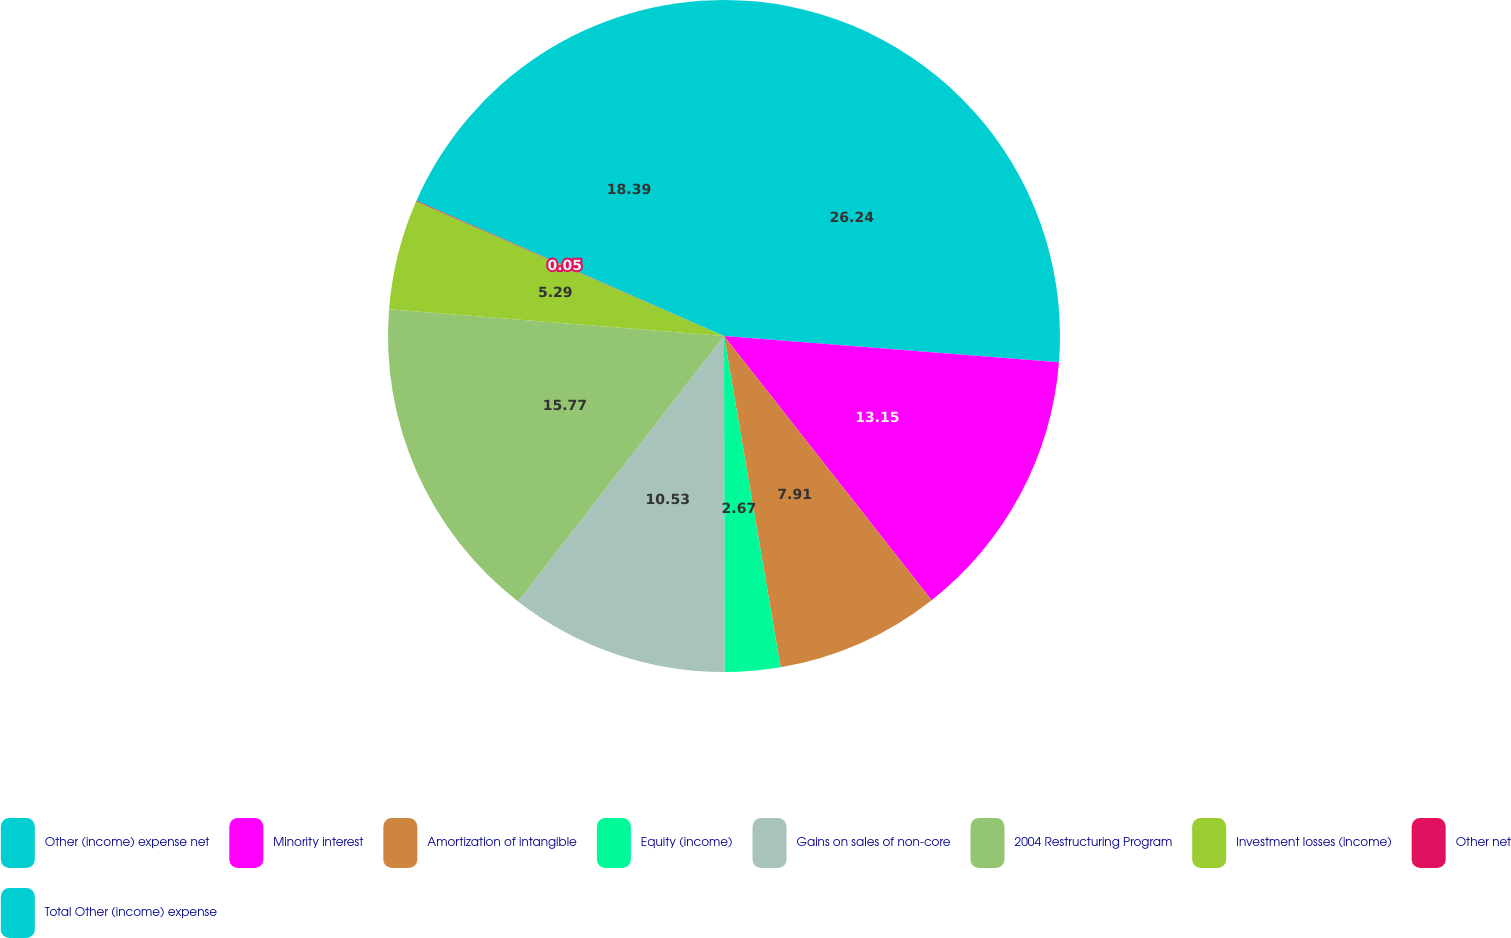<chart> <loc_0><loc_0><loc_500><loc_500><pie_chart><fcel>Other (income) expense net<fcel>Minority interest<fcel>Amortization of intangible<fcel>Equity (income)<fcel>Gains on sales of non-core<fcel>2004 Restructuring Program<fcel>Investment losses (income)<fcel>Other net<fcel>Total Other (income) expense<nl><fcel>26.25%<fcel>13.15%<fcel>7.91%<fcel>2.67%<fcel>10.53%<fcel>15.77%<fcel>5.29%<fcel>0.05%<fcel>18.39%<nl></chart> 